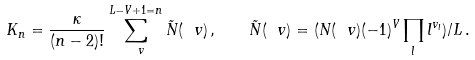<formula> <loc_0><loc_0><loc_500><loc_500>K _ { n } = \frac { \kappa } { ( n - 2 ) ! } \sum _ { \ v } ^ { L - V + 1 = n } \tilde { N } ( \ v ) \, , \quad \tilde { N } ( \ v ) = ( N ( \ v ) ( - 1 ) ^ { V } \prod _ { l } l ^ { v _ { l } } ) / L \, .</formula> 